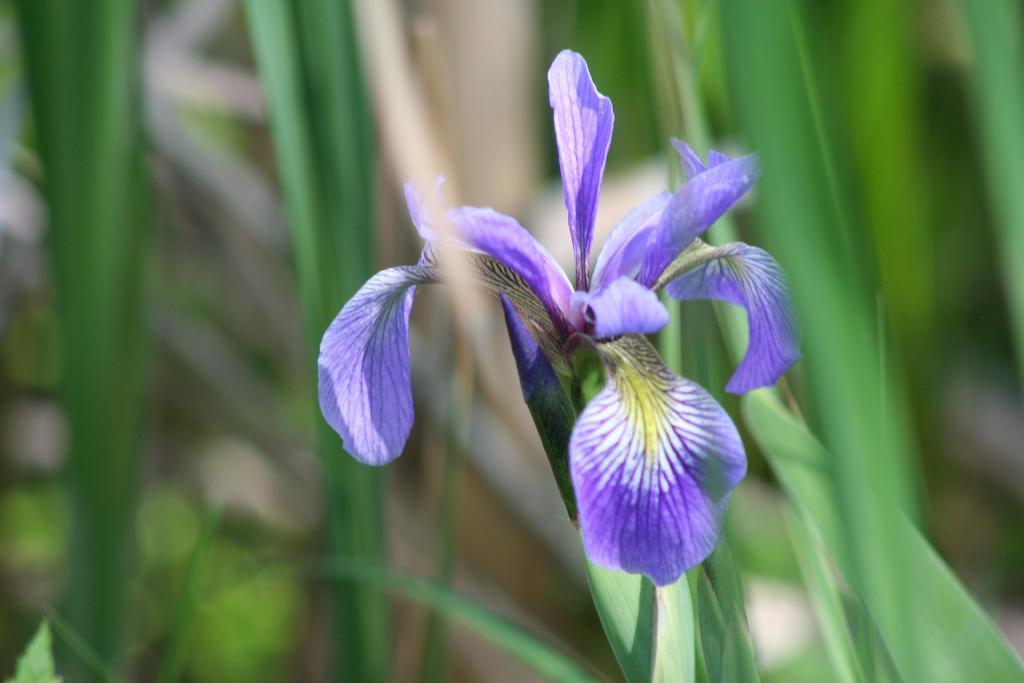Could you give a brief overview of what you see in this image? In this picture I can see the flower plant. 